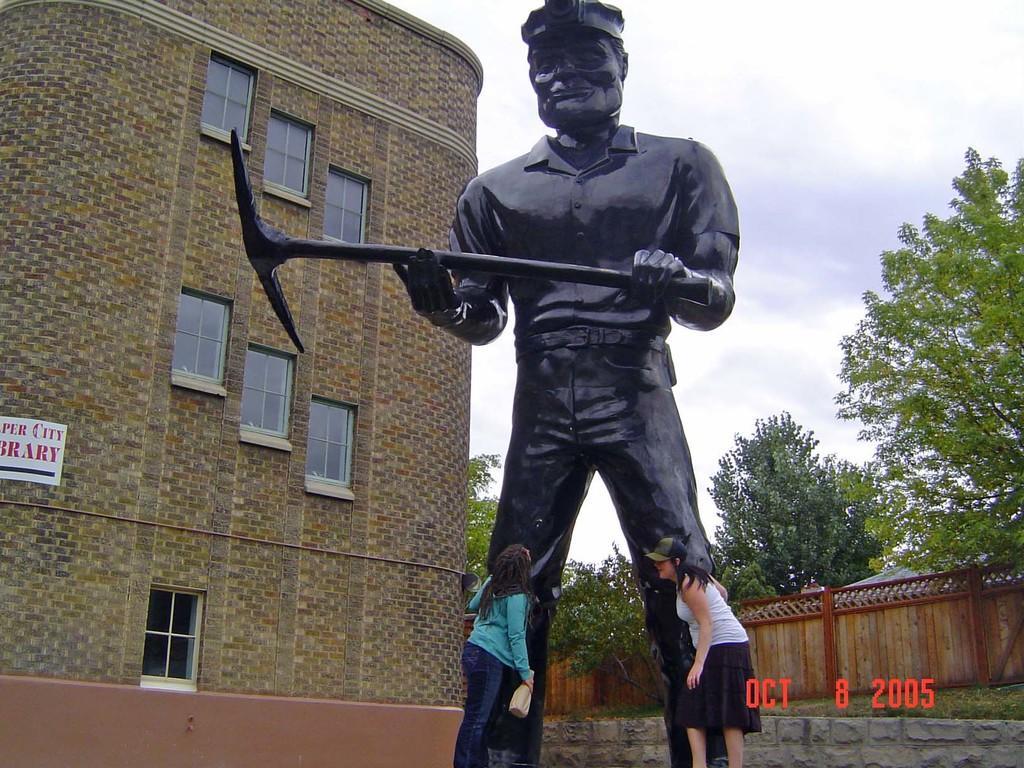How would you summarize this image in a sentence or two? This is an outside view. Here I can see a statue of a person holding an object in the hands. At the bottom of this statue two women are standing. On the left side there is a building. In the background I can see fencing and trees. At the top of the image I can see the sky. 